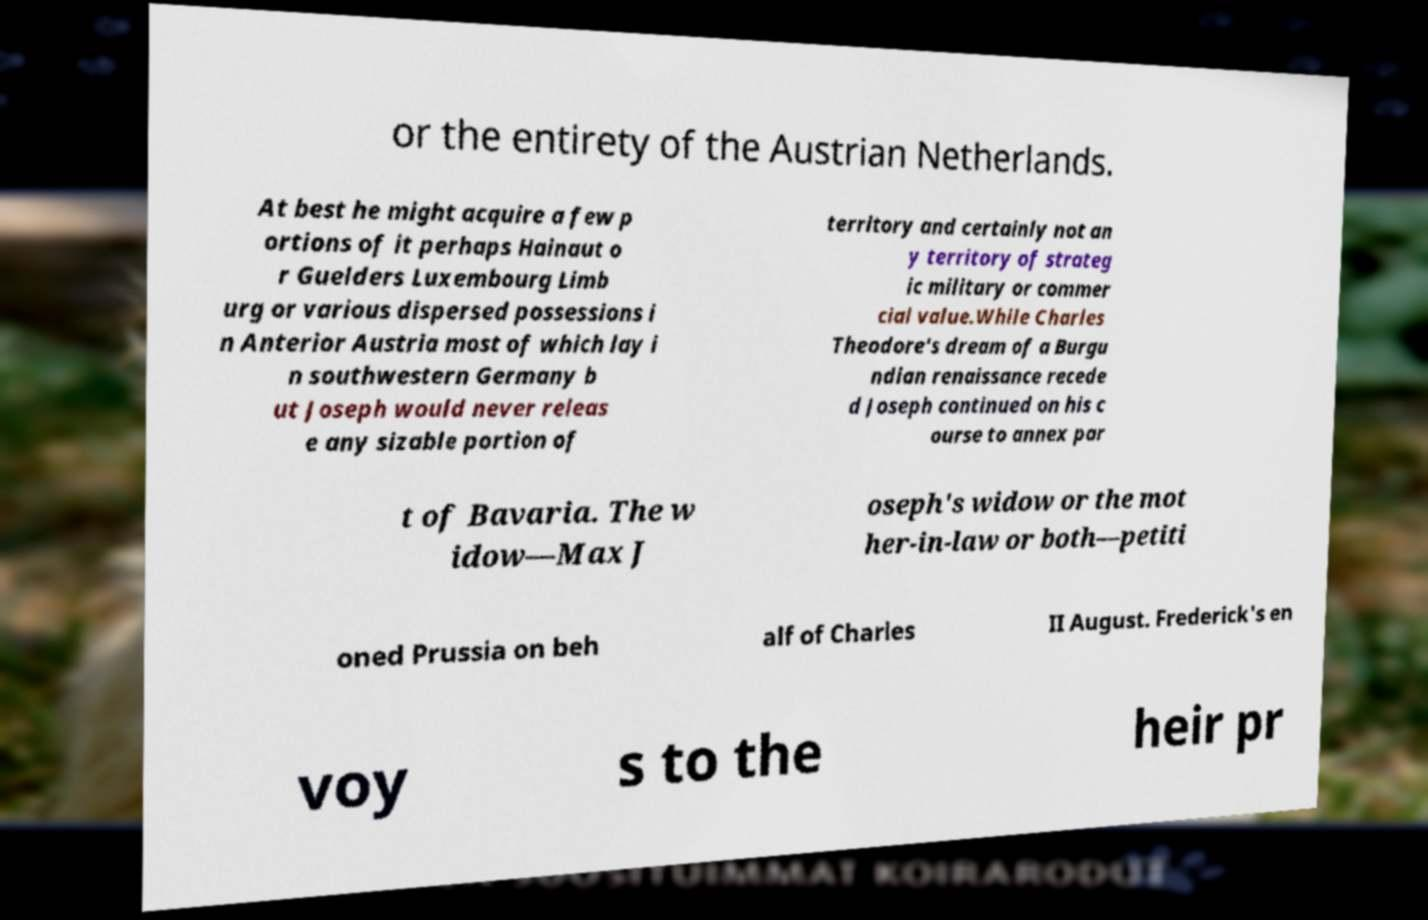Can you read and provide the text displayed in the image?This photo seems to have some interesting text. Can you extract and type it out for me? or the entirety of the Austrian Netherlands. At best he might acquire a few p ortions of it perhaps Hainaut o r Guelders Luxembourg Limb urg or various dispersed possessions i n Anterior Austria most of which lay i n southwestern Germany b ut Joseph would never releas e any sizable portion of territory and certainly not an y territory of strateg ic military or commer cial value.While Charles Theodore's dream of a Burgu ndian renaissance recede d Joseph continued on his c ourse to annex par t of Bavaria. The w idow—Max J oseph's widow or the mot her-in-law or both—petiti oned Prussia on beh alf of Charles II August. Frederick's en voy s to the heir pr 